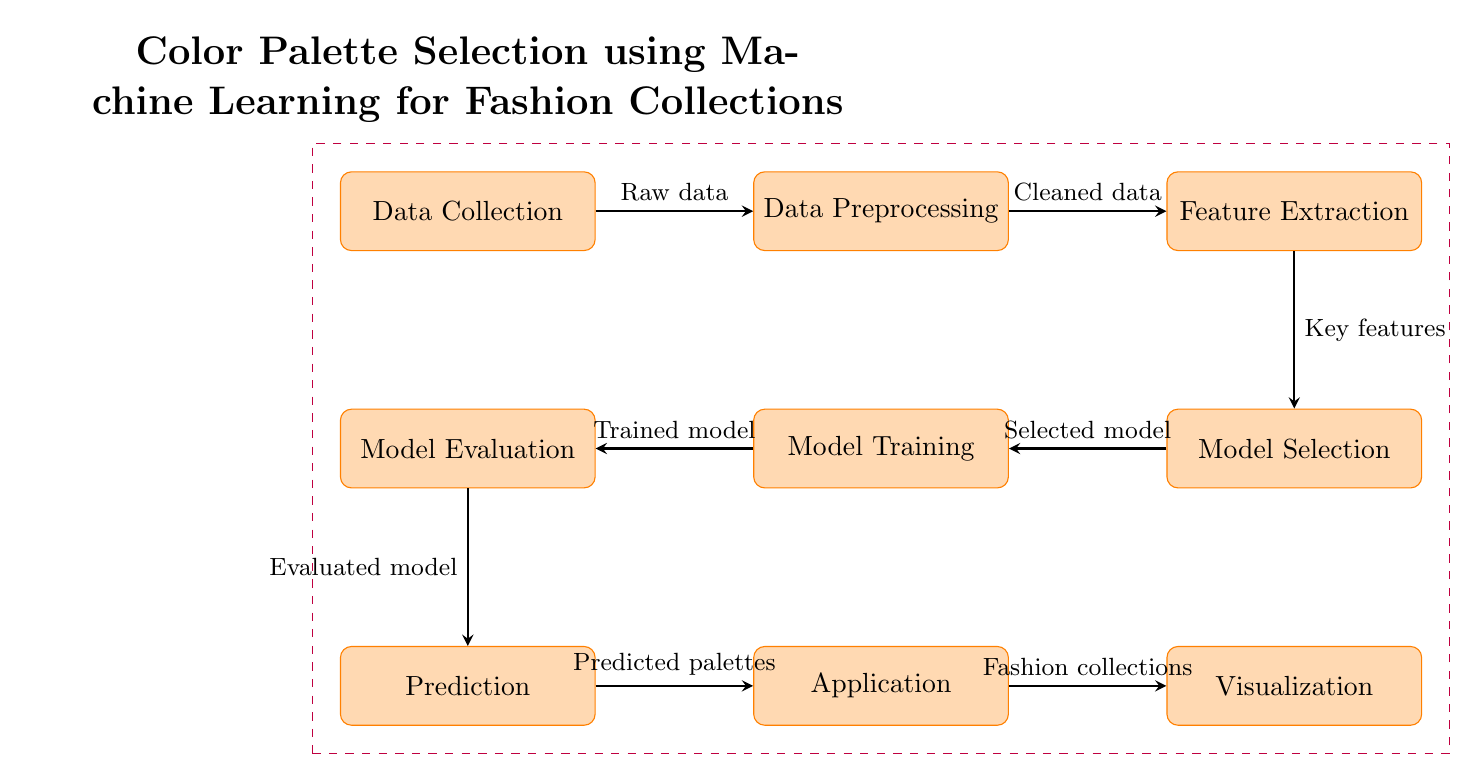What is the first step in the diagram? The first step in the diagram is labeled as "Data Collection." This is the starting point and is positioned at the top left of the flow.
Answer: Data Collection How many processes are depicted in the diagram? The diagram displays a total of eight processes, counting from "Data Collection" through to "Visualization."
Answer: Eight processes What does the arrow between "Data Collection" and "Data Preprocessing" indicate? The arrow signifies the flow of information, specifically that raw data is being processed and transformed into cleaned data at the next step.
Answer: Raw data Which node receives input from the "Model Evaluation"? The "Prediction" node directly follows "Model Evaluation" and receives the evaluated model as input to generate predictions.
Answer: Prediction What is the output from the "Application" node? The output from the "Application" node refers to "Predicted palettes." This indicates what the application generates after processing.
Answer: Predicted palettes How does "Feature Extraction" connect to "Model Selection"? "Feature Extraction" connects to "Model Selection" through an arrow that indicates the transfer of key features, which are important for choosing the model.
Answer: Key features Which step comes after "Model Training"? The step that follows "Model Training" is "Model Evaluation," where the trained model is evaluated for its performance.
Answer: Model Evaluation What is the relationship between "Prediction" and "Application"? The relationship is indicated by an arrow, showing that the prediction step outputs predicted palettes, which are then used in the application step for fashion collections.
Answer: Predicted palettes What is the last process in the workflow? The final process in the workflow, as seen in the diagram, is "Visualization." This is where the outcomes are visually represented for analysis or interpretation.
Answer: Visualization 